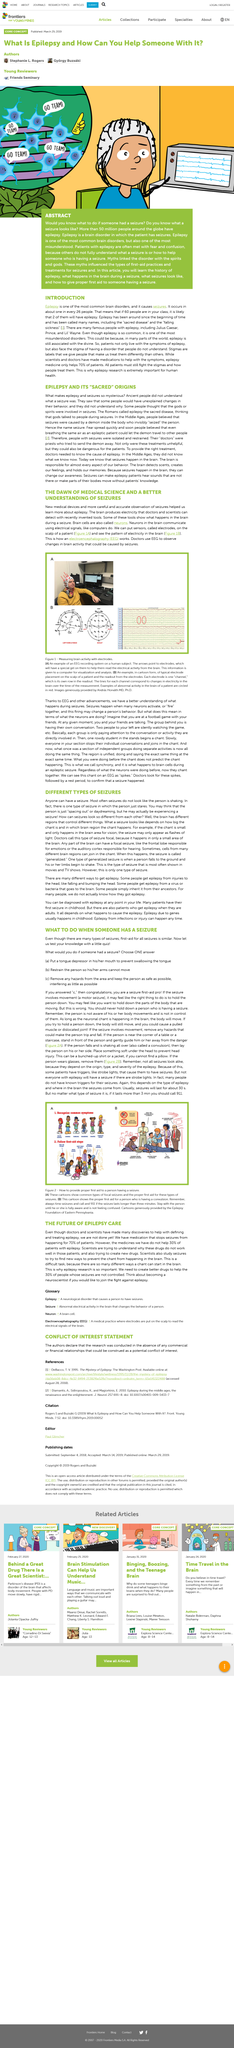Outline some significant characteristics in this image. Electrodes are secured on the human head through the use of gel and a cap, which ensures proper placement and conductivity during medical procedures or testing. The EEG readout represents the data from one electrode, which corresponds to one row of the output. If a seizure lasts longer than three minutes, it is recommended that emergency services be called. Electrodes can assist doctors in better understanding epileptic seizures. It is not appropriate to hold down a person who is having a seizure. 